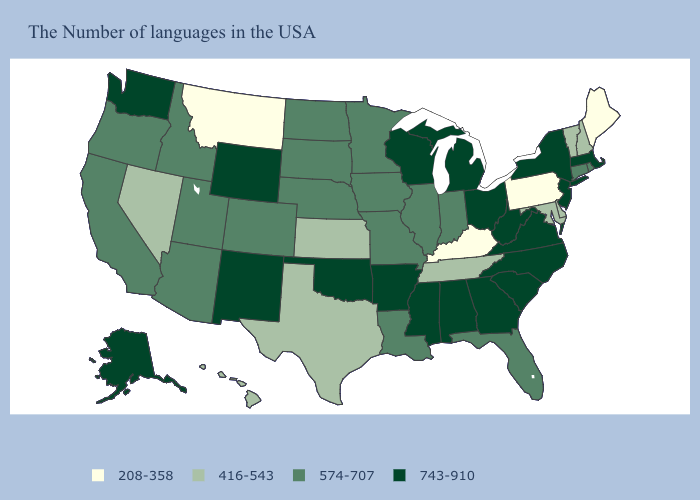What is the lowest value in the USA?
Answer briefly. 208-358. Name the states that have a value in the range 743-910?
Be succinct. Massachusetts, New York, New Jersey, Virginia, North Carolina, South Carolina, West Virginia, Ohio, Georgia, Michigan, Alabama, Wisconsin, Mississippi, Arkansas, Oklahoma, Wyoming, New Mexico, Washington, Alaska. Among the states that border Oregon , which have the lowest value?
Concise answer only. Nevada. Among the states that border Pennsylvania , does Delaware have the highest value?
Quick response, please. No. How many symbols are there in the legend?
Quick response, please. 4. Name the states that have a value in the range 208-358?
Be succinct. Maine, Pennsylvania, Kentucky, Montana. Name the states that have a value in the range 416-543?
Short answer required. New Hampshire, Vermont, Delaware, Maryland, Tennessee, Kansas, Texas, Nevada, Hawaii. Does the first symbol in the legend represent the smallest category?
Quick response, please. Yes. Name the states that have a value in the range 208-358?
Be succinct. Maine, Pennsylvania, Kentucky, Montana. What is the value of West Virginia?
Concise answer only. 743-910. How many symbols are there in the legend?
Be succinct. 4. Name the states that have a value in the range 743-910?
Give a very brief answer. Massachusetts, New York, New Jersey, Virginia, North Carolina, South Carolina, West Virginia, Ohio, Georgia, Michigan, Alabama, Wisconsin, Mississippi, Arkansas, Oklahoma, Wyoming, New Mexico, Washington, Alaska. Name the states that have a value in the range 743-910?
Keep it brief. Massachusetts, New York, New Jersey, Virginia, North Carolina, South Carolina, West Virginia, Ohio, Georgia, Michigan, Alabama, Wisconsin, Mississippi, Arkansas, Oklahoma, Wyoming, New Mexico, Washington, Alaska. Name the states that have a value in the range 574-707?
Answer briefly. Rhode Island, Connecticut, Florida, Indiana, Illinois, Louisiana, Missouri, Minnesota, Iowa, Nebraska, South Dakota, North Dakota, Colorado, Utah, Arizona, Idaho, California, Oregon. Name the states that have a value in the range 416-543?
Concise answer only. New Hampshire, Vermont, Delaware, Maryland, Tennessee, Kansas, Texas, Nevada, Hawaii. 